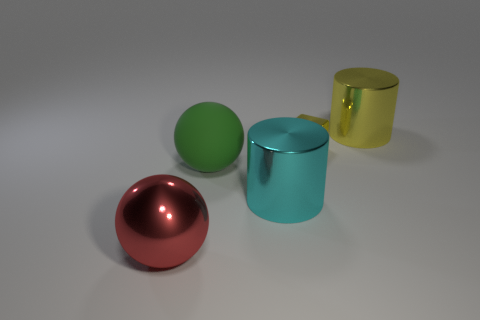There is a large thing that is both to the right of the green thing and in front of the large yellow cylinder; what is its shape? cylinder 